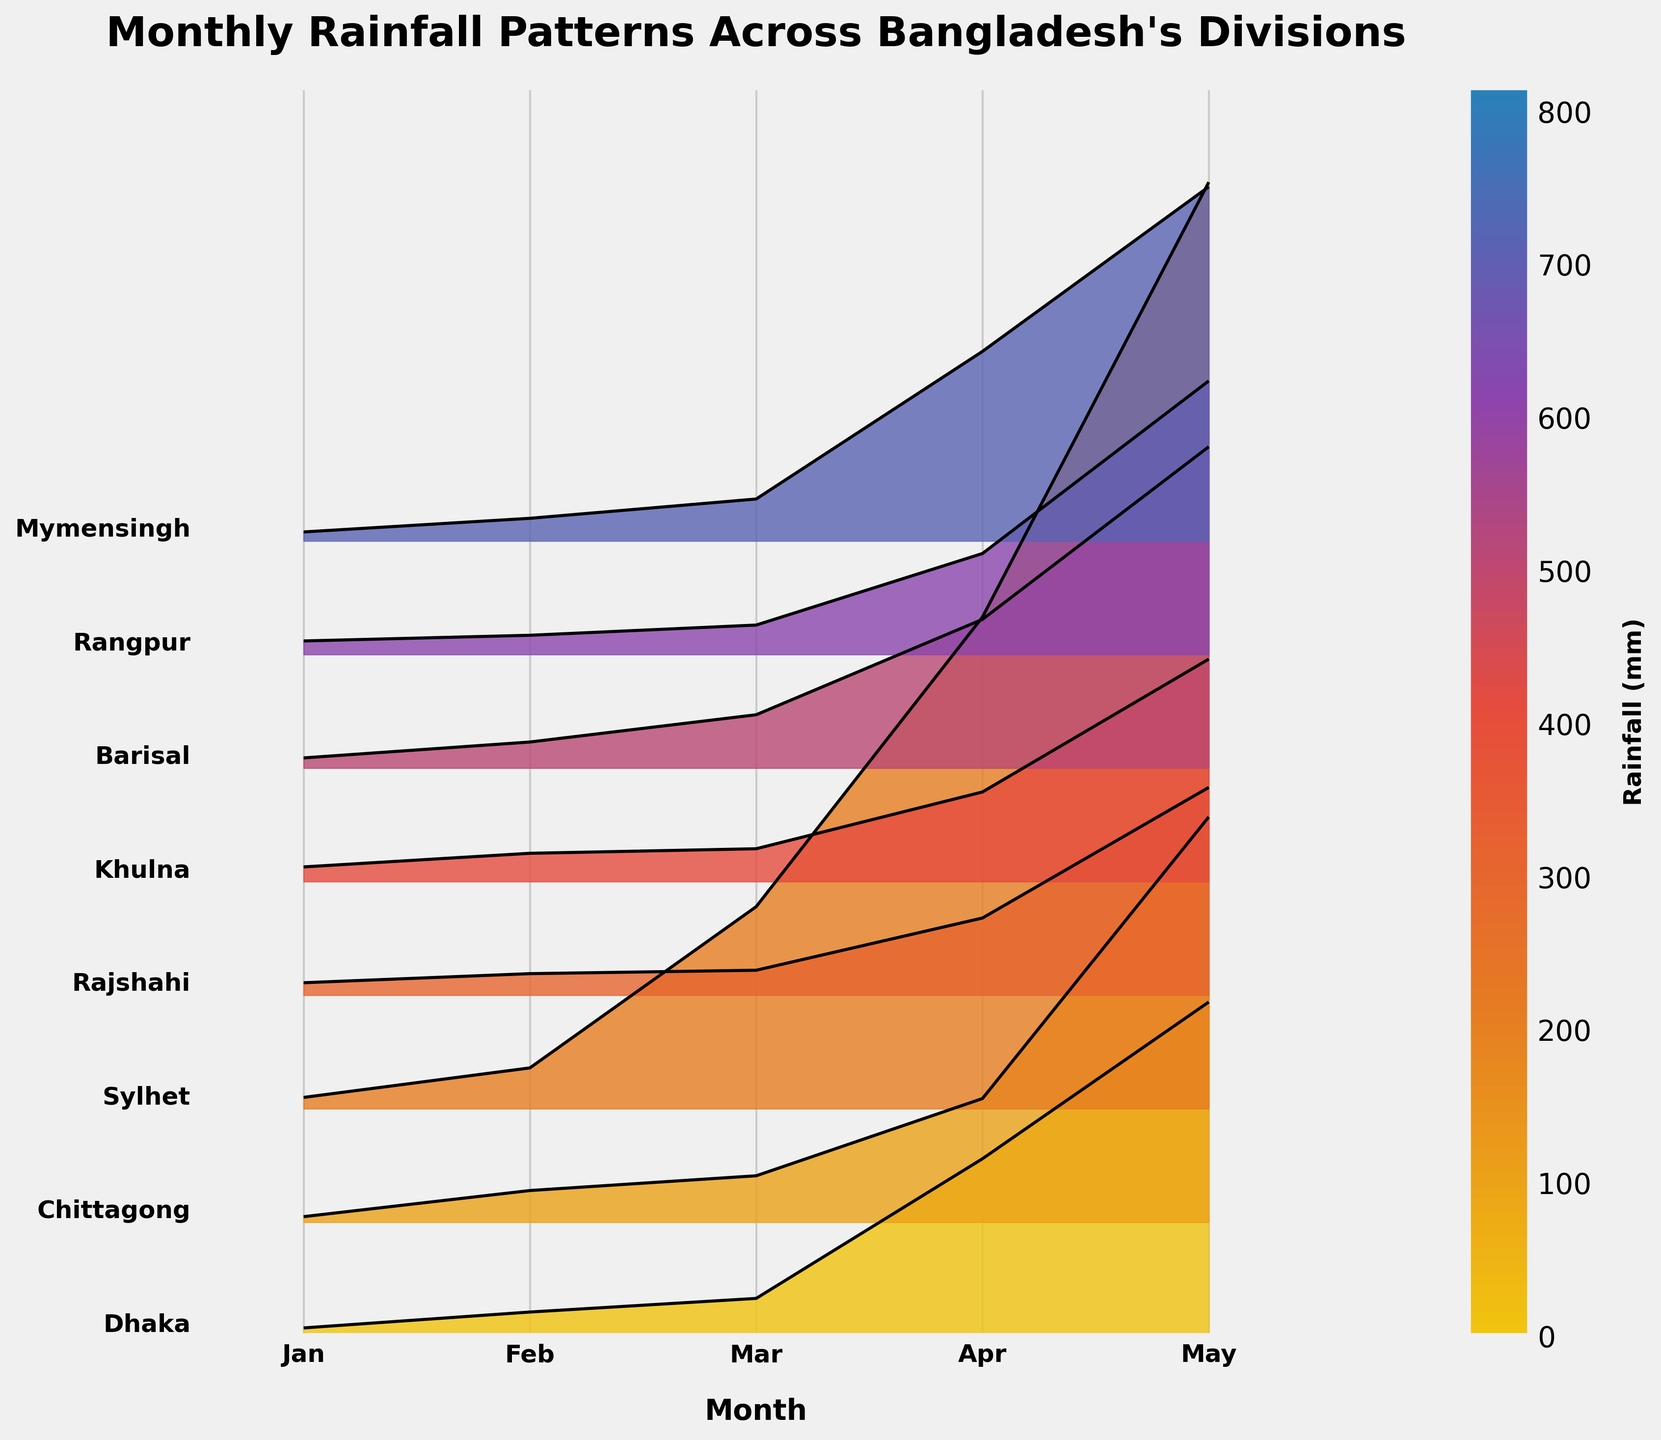What is the title of the plot? The title is located at the top of the plot and is usually displayed in a larger and bold font to make it easy to identify.
Answer: Monthly Rainfall Patterns Across Bangladesh's Divisions Which division experienced the highest rainfall in May? Locate the division with the tallest peak in May (the last month on the x-axis). Sylhet has the highest peak in May.
Answer: Sylhet How many months are represented on the x-axis? Count the number of labeled ticks along the x-axis. There are five months labeled from January to May.
Answer: 5 Which division has the least rainfall in January? Find the shortest peak in January (the first month on the x-axis). Dhaka has the least rainfall with a shortest peak in January.
Answer: Dhaka In which month does Barisal experience its peak rainfall? Locate the highest peak for Barisal across the five months, noting the x-axis label corresponding to this peak. The peak for Barisal occurs in May.
Answer: May Compare the rainfall pattern between Dhaka and Chittagong. Which division generally experiences more rainfall? By comparing the heights of the peaks for each month between Dhaka (the first division) and Chittagong (the second division), Chittagong generally has taller peaks, indicating more rainfall.
Answer: Chittagong Which month sees the highest overall rainfall across all divisions? Sum up the heights of the peaks per month across all divisions and compare. May exhibits the highest overall rainfall with the most and tallest peaks collectively.
Answer: May What is the maximum rainfall recorded and in which division and month did it occur? Identify the tallest peak in the entire plot and check the corresponding division and month. The maximum rainfall recorded is in Sylhet in May.
Answer: Sylhet in May Which division has the most consistent (least varied) rainfall across the months? Assess the uniformity of peak heights for each division. Khulna shows very consistent peaks, indicating lesser variation in rainfall across months.
Answer: Khulna Rank the divisions based on their peak rainfall in April from highest to lowest. Look at the peaks for April (the fourth month) and compare their heights. The order is Sylhet, Dhaka, Barisal, Mymensingh, Khulna, Rangpur, Chittagong, Rajshahi.
Answer: Sylhet, Dhaka, Barisal, Mymensingh, Khulna, Rangpur, Chittagong, Rajshahi 